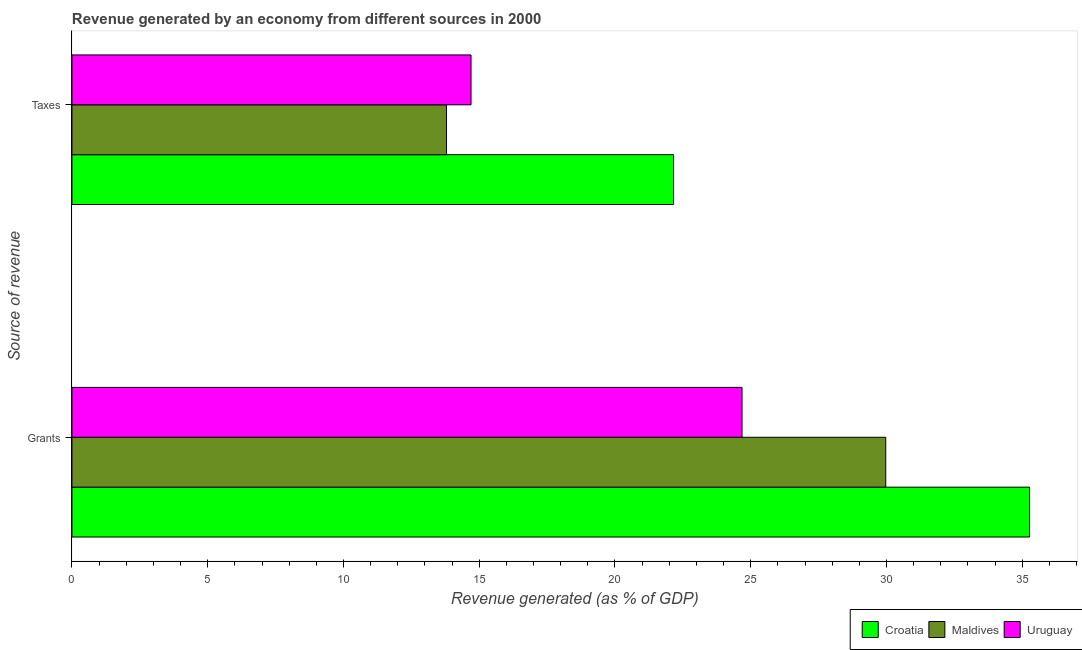Are the number of bars on each tick of the Y-axis equal?
Make the answer very short. Yes. How many bars are there on the 1st tick from the top?
Provide a succinct answer. 3. How many bars are there on the 2nd tick from the bottom?
Keep it short and to the point. 3. What is the label of the 2nd group of bars from the top?
Offer a terse response. Grants. What is the revenue generated by grants in Maldives?
Provide a short and direct response. 29.97. Across all countries, what is the maximum revenue generated by taxes?
Keep it short and to the point. 22.16. Across all countries, what is the minimum revenue generated by grants?
Keep it short and to the point. 24.68. In which country was the revenue generated by grants maximum?
Give a very brief answer. Croatia. In which country was the revenue generated by taxes minimum?
Your answer should be very brief. Maldives. What is the total revenue generated by grants in the graph?
Your response must be concise. 89.93. What is the difference between the revenue generated by taxes in Croatia and that in Maldives?
Keep it short and to the point. 8.36. What is the difference between the revenue generated by taxes in Uruguay and the revenue generated by grants in Croatia?
Offer a very short reply. -20.57. What is the average revenue generated by grants per country?
Your response must be concise. 29.98. What is the difference between the revenue generated by taxes and revenue generated by grants in Croatia?
Provide a short and direct response. -13.11. What is the ratio of the revenue generated by grants in Croatia to that in Maldives?
Offer a terse response. 1.18. What does the 2nd bar from the top in Taxes represents?
Your answer should be compact. Maldives. What does the 1st bar from the bottom in Grants represents?
Your response must be concise. Croatia. Are all the bars in the graph horizontal?
Keep it short and to the point. Yes. How many countries are there in the graph?
Provide a succinct answer. 3. What is the difference between two consecutive major ticks on the X-axis?
Your answer should be very brief. 5. Are the values on the major ticks of X-axis written in scientific E-notation?
Your response must be concise. No. Where does the legend appear in the graph?
Ensure brevity in your answer.  Bottom right. How many legend labels are there?
Your response must be concise. 3. What is the title of the graph?
Your answer should be compact. Revenue generated by an economy from different sources in 2000. Does "Bangladesh" appear as one of the legend labels in the graph?
Offer a very short reply. No. What is the label or title of the X-axis?
Your response must be concise. Revenue generated (as % of GDP). What is the label or title of the Y-axis?
Offer a terse response. Source of revenue. What is the Revenue generated (as % of GDP) of Croatia in Grants?
Offer a very short reply. 35.27. What is the Revenue generated (as % of GDP) of Maldives in Grants?
Ensure brevity in your answer.  29.97. What is the Revenue generated (as % of GDP) of Uruguay in Grants?
Provide a succinct answer. 24.68. What is the Revenue generated (as % of GDP) of Croatia in Taxes?
Provide a succinct answer. 22.16. What is the Revenue generated (as % of GDP) in Maldives in Taxes?
Your answer should be very brief. 13.8. What is the Revenue generated (as % of GDP) of Uruguay in Taxes?
Your response must be concise. 14.7. Across all Source of revenue, what is the maximum Revenue generated (as % of GDP) in Croatia?
Ensure brevity in your answer.  35.27. Across all Source of revenue, what is the maximum Revenue generated (as % of GDP) of Maldives?
Provide a succinct answer. 29.97. Across all Source of revenue, what is the maximum Revenue generated (as % of GDP) of Uruguay?
Provide a short and direct response. 24.68. Across all Source of revenue, what is the minimum Revenue generated (as % of GDP) of Croatia?
Your answer should be compact. 22.16. Across all Source of revenue, what is the minimum Revenue generated (as % of GDP) of Maldives?
Your response must be concise. 13.8. Across all Source of revenue, what is the minimum Revenue generated (as % of GDP) in Uruguay?
Ensure brevity in your answer.  14.7. What is the total Revenue generated (as % of GDP) in Croatia in the graph?
Offer a very short reply. 57.43. What is the total Revenue generated (as % of GDP) in Maldives in the graph?
Your response must be concise. 43.77. What is the total Revenue generated (as % of GDP) in Uruguay in the graph?
Provide a short and direct response. 39.38. What is the difference between the Revenue generated (as % of GDP) in Croatia in Grants and that in Taxes?
Your answer should be very brief. 13.11. What is the difference between the Revenue generated (as % of GDP) of Maldives in Grants and that in Taxes?
Ensure brevity in your answer.  16.18. What is the difference between the Revenue generated (as % of GDP) in Uruguay in Grants and that in Taxes?
Your answer should be very brief. 9.98. What is the difference between the Revenue generated (as % of GDP) in Croatia in Grants and the Revenue generated (as % of GDP) in Maldives in Taxes?
Provide a succinct answer. 21.48. What is the difference between the Revenue generated (as % of GDP) in Croatia in Grants and the Revenue generated (as % of GDP) in Uruguay in Taxes?
Give a very brief answer. 20.57. What is the difference between the Revenue generated (as % of GDP) of Maldives in Grants and the Revenue generated (as % of GDP) of Uruguay in Taxes?
Offer a very short reply. 15.27. What is the average Revenue generated (as % of GDP) in Croatia per Source of revenue?
Offer a very short reply. 28.72. What is the average Revenue generated (as % of GDP) of Maldives per Source of revenue?
Ensure brevity in your answer.  21.88. What is the average Revenue generated (as % of GDP) in Uruguay per Source of revenue?
Offer a very short reply. 19.69. What is the difference between the Revenue generated (as % of GDP) of Croatia and Revenue generated (as % of GDP) of Maldives in Grants?
Give a very brief answer. 5.3. What is the difference between the Revenue generated (as % of GDP) in Croatia and Revenue generated (as % of GDP) in Uruguay in Grants?
Offer a very short reply. 10.59. What is the difference between the Revenue generated (as % of GDP) in Maldives and Revenue generated (as % of GDP) in Uruguay in Grants?
Your response must be concise. 5.29. What is the difference between the Revenue generated (as % of GDP) of Croatia and Revenue generated (as % of GDP) of Maldives in Taxes?
Give a very brief answer. 8.36. What is the difference between the Revenue generated (as % of GDP) of Croatia and Revenue generated (as % of GDP) of Uruguay in Taxes?
Make the answer very short. 7.46. What is the difference between the Revenue generated (as % of GDP) of Maldives and Revenue generated (as % of GDP) of Uruguay in Taxes?
Ensure brevity in your answer.  -0.9. What is the ratio of the Revenue generated (as % of GDP) of Croatia in Grants to that in Taxes?
Offer a terse response. 1.59. What is the ratio of the Revenue generated (as % of GDP) in Maldives in Grants to that in Taxes?
Your answer should be very brief. 2.17. What is the ratio of the Revenue generated (as % of GDP) in Uruguay in Grants to that in Taxes?
Give a very brief answer. 1.68. What is the difference between the highest and the second highest Revenue generated (as % of GDP) of Croatia?
Give a very brief answer. 13.11. What is the difference between the highest and the second highest Revenue generated (as % of GDP) of Maldives?
Your response must be concise. 16.18. What is the difference between the highest and the second highest Revenue generated (as % of GDP) of Uruguay?
Provide a succinct answer. 9.98. What is the difference between the highest and the lowest Revenue generated (as % of GDP) of Croatia?
Provide a succinct answer. 13.11. What is the difference between the highest and the lowest Revenue generated (as % of GDP) of Maldives?
Ensure brevity in your answer.  16.18. What is the difference between the highest and the lowest Revenue generated (as % of GDP) in Uruguay?
Provide a succinct answer. 9.98. 